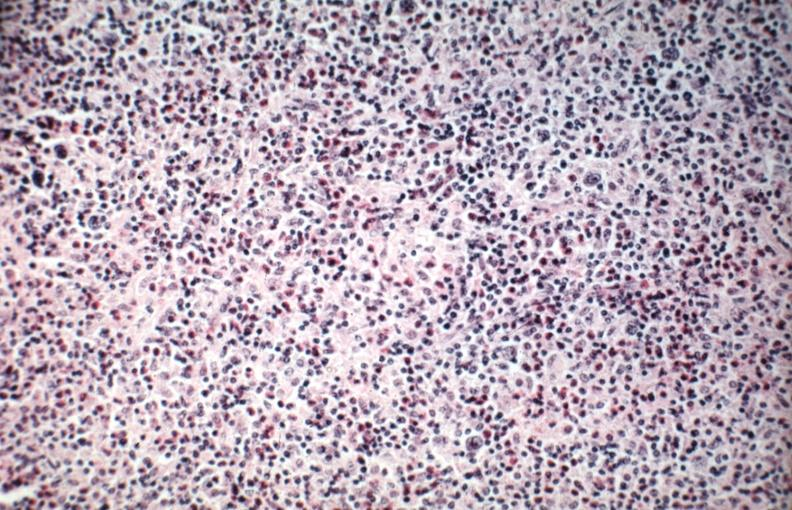s lymph node present?
Answer the question using a single word or phrase. Yes 